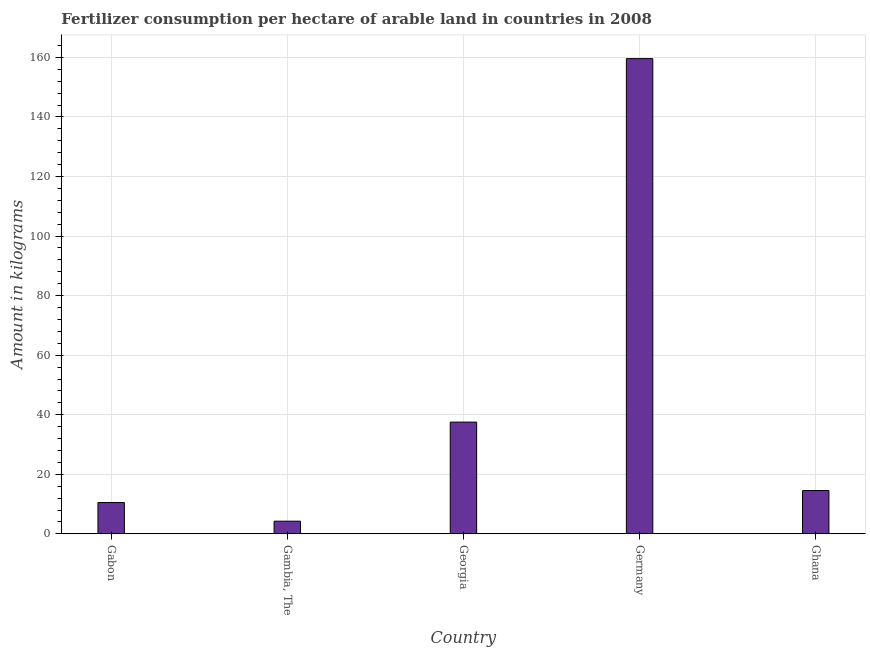Does the graph contain any zero values?
Make the answer very short. No. Does the graph contain grids?
Give a very brief answer. Yes. What is the title of the graph?
Your response must be concise. Fertilizer consumption per hectare of arable land in countries in 2008 . What is the label or title of the Y-axis?
Keep it short and to the point. Amount in kilograms. What is the amount of fertilizer consumption in Gambia, The?
Offer a terse response. 4.26. Across all countries, what is the maximum amount of fertilizer consumption?
Keep it short and to the point. 159.58. Across all countries, what is the minimum amount of fertilizer consumption?
Make the answer very short. 4.26. In which country was the amount of fertilizer consumption maximum?
Make the answer very short. Germany. In which country was the amount of fertilizer consumption minimum?
Your response must be concise. Gambia, The. What is the sum of the amount of fertilizer consumption?
Offer a very short reply. 226.44. What is the difference between the amount of fertilizer consumption in Gambia, The and Ghana?
Offer a terse response. -10.29. What is the average amount of fertilizer consumption per country?
Your response must be concise. 45.29. What is the median amount of fertilizer consumption?
Give a very brief answer. 14.55. In how many countries, is the amount of fertilizer consumption greater than 144 kg?
Provide a succinct answer. 1. What is the ratio of the amount of fertilizer consumption in Gabon to that in Ghana?
Offer a terse response. 0.72. Is the difference between the amount of fertilizer consumption in Georgia and Germany greater than the difference between any two countries?
Make the answer very short. No. What is the difference between the highest and the second highest amount of fertilizer consumption?
Keep it short and to the point. 122.05. Is the sum of the amount of fertilizer consumption in Germany and Ghana greater than the maximum amount of fertilizer consumption across all countries?
Your answer should be very brief. Yes. What is the difference between the highest and the lowest amount of fertilizer consumption?
Your response must be concise. 155.32. Are all the bars in the graph horizontal?
Keep it short and to the point. No. Are the values on the major ticks of Y-axis written in scientific E-notation?
Ensure brevity in your answer.  No. What is the Amount in kilograms of Gabon?
Offer a terse response. 10.52. What is the Amount in kilograms in Gambia, The?
Your answer should be very brief. 4.26. What is the Amount in kilograms of Georgia?
Provide a short and direct response. 37.53. What is the Amount in kilograms in Germany?
Keep it short and to the point. 159.58. What is the Amount in kilograms of Ghana?
Offer a very short reply. 14.55. What is the difference between the Amount in kilograms in Gabon and Gambia, The?
Offer a very short reply. 6.26. What is the difference between the Amount in kilograms in Gabon and Georgia?
Offer a very short reply. -27.01. What is the difference between the Amount in kilograms in Gabon and Germany?
Keep it short and to the point. -149.07. What is the difference between the Amount in kilograms in Gabon and Ghana?
Provide a short and direct response. -4.03. What is the difference between the Amount in kilograms in Gambia, The and Georgia?
Your answer should be compact. -33.27. What is the difference between the Amount in kilograms in Gambia, The and Germany?
Ensure brevity in your answer.  -155.32. What is the difference between the Amount in kilograms in Gambia, The and Ghana?
Give a very brief answer. -10.29. What is the difference between the Amount in kilograms in Georgia and Germany?
Ensure brevity in your answer.  -122.05. What is the difference between the Amount in kilograms in Georgia and Ghana?
Your answer should be very brief. 22.98. What is the difference between the Amount in kilograms in Germany and Ghana?
Make the answer very short. 145.03. What is the ratio of the Amount in kilograms in Gabon to that in Gambia, The?
Offer a terse response. 2.47. What is the ratio of the Amount in kilograms in Gabon to that in Georgia?
Your answer should be very brief. 0.28. What is the ratio of the Amount in kilograms in Gabon to that in Germany?
Provide a succinct answer. 0.07. What is the ratio of the Amount in kilograms in Gabon to that in Ghana?
Provide a succinct answer. 0.72. What is the ratio of the Amount in kilograms in Gambia, The to that in Georgia?
Your answer should be very brief. 0.11. What is the ratio of the Amount in kilograms in Gambia, The to that in Germany?
Give a very brief answer. 0.03. What is the ratio of the Amount in kilograms in Gambia, The to that in Ghana?
Provide a short and direct response. 0.29. What is the ratio of the Amount in kilograms in Georgia to that in Germany?
Offer a terse response. 0.23. What is the ratio of the Amount in kilograms in Georgia to that in Ghana?
Ensure brevity in your answer.  2.58. What is the ratio of the Amount in kilograms in Germany to that in Ghana?
Your response must be concise. 10.97. 